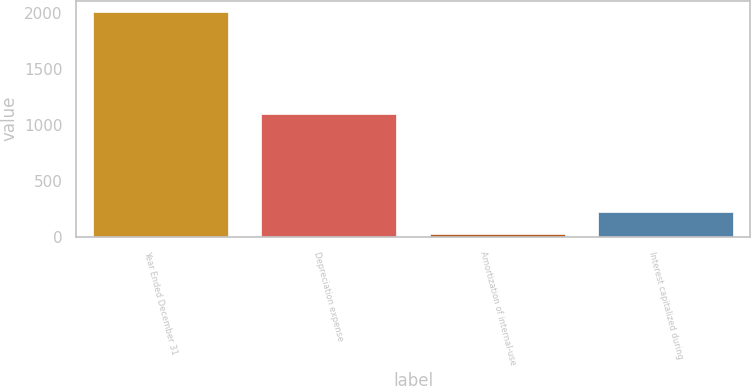Convert chart. <chart><loc_0><loc_0><loc_500><loc_500><bar_chart><fcel>Year Ended December 31<fcel>Depreciation expense<fcel>Amortization of internal-use<fcel>Interest capitalized during<nl><fcel>2015<fcel>1104<fcel>29<fcel>227.6<nl></chart> 